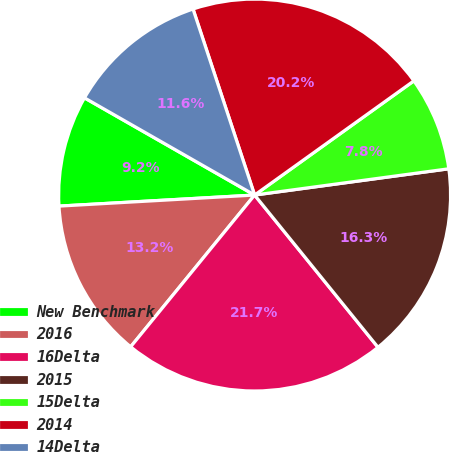Convert chart to OTSL. <chart><loc_0><loc_0><loc_500><loc_500><pie_chart><fcel>New Benchmark<fcel>2016<fcel>16Delta<fcel>2015<fcel>15Delta<fcel>2014<fcel>14Delta<nl><fcel>9.16%<fcel>13.2%<fcel>21.74%<fcel>16.3%<fcel>7.76%<fcel>20.19%<fcel>11.65%<nl></chart> 